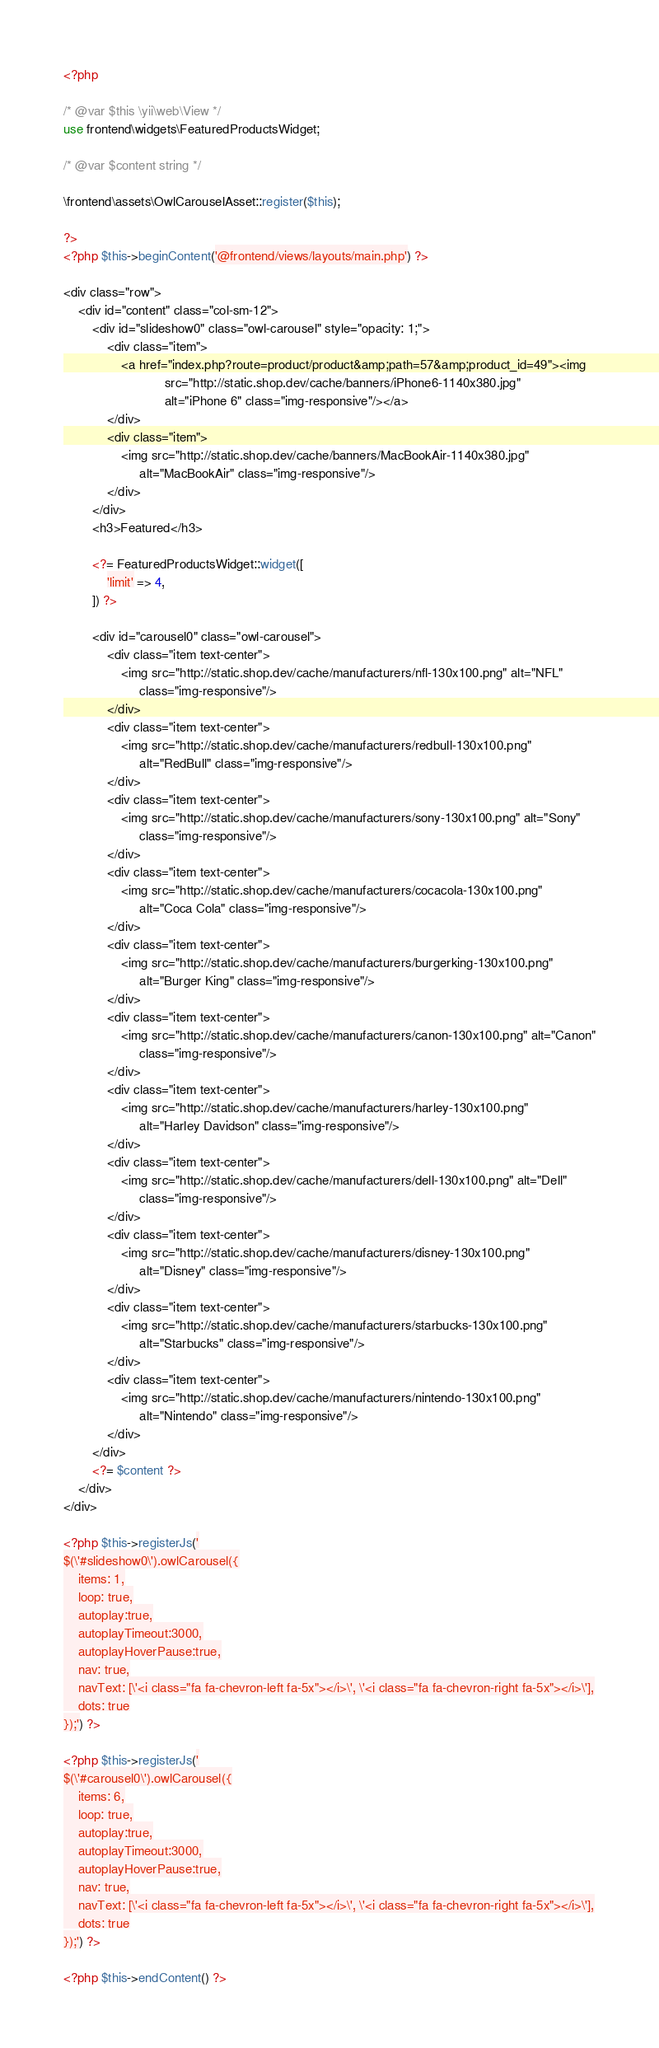<code> <loc_0><loc_0><loc_500><loc_500><_PHP_><?php

/* @var $this \yii\web\View */
use frontend\widgets\FeaturedProductsWidget;

/* @var $content string */

\frontend\assets\OwlCarouselAsset::register($this);

?>
<?php $this->beginContent('@frontend/views/layouts/main.php') ?>

<div class="row">
    <div id="content" class="col-sm-12">
        <div id="slideshow0" class="owl-carousel" style="opacity: 1;">
            <div class="item">
                <a href="index.php?route=product/product&amp;path=57&amp;product_id=49"><img
                            src="http://static.shop.dev/cache/banners/iPhone6-1140x380.jpg"
                            alt="iPhone 6" class="img-responsive"/></a>
            </div>
            <div class="item">
                <img src="http://static.shop.dev/cache/banners/MacBookAir-1140x380.jpg"
                     alt="MacBookAir" class="img-responsive"/>
            </div>
        </div>
        <h3>Featured</h3>

        <?= FeaturedProductsWidget::widget([
            'limit' => 4,
        ]) ?>

        <div id="carousel0" class="owl-carousel">
            <div class="item text-center">
                <img src="http://static.shop.dev/cache/manufacturers/nfl-130x100.png" alt="NFL"
                     class="img-responsive"/>
            </div>
            <div class="item text-center">
                <img src="http://static.shop.dev/cache/manufacturers/redbull-130x100.png"
                     alt="RedBull" class="img-responsive"/>
            </div>
            <div class="item text-center">
                <img src="http://static.shop.dev/cache/manufacturers/sony-130x100.png" alt="Sony"
                     class="img-responsive"/>
            </div>
            <div class="item text-center">
                <img src="http://static.shop.dev/cache/manufacturers/cocacola-130x100.png"
                     alt="Coca Cola" class="img-responsive"/>
            </div>
            <div class="item text-center">
                <img src="http://static.shop.dev/cache/manufacturers/burgerking-130x100.png"
                     alt="Burger King" class="img-responsive"/>
            </div>
            <div class="item text-center">
                <img src="http://static.shop.dev/cache/manufacturers/canon-130x100.png" alt="Canon"
                     class="img-responsive"/>
            </div>
            <div class="item text-center">
                <img src="http://static.shop.dev/cache/manufacturers/harley-130x100.png"
                     alt="Harley Davidson" class="img-responsive"/>
            </div>
            <div class="item text-center">
                <img src="http://static.shop.dev/cache/manufacturers/dell-130x100.png" alt="Dell"
                     class="img-responsive"/>
            </div>
            <div class="item text-center">
                <img src="http://static.shop.dev/cache/manufacturers/disney-130x100.png"
                     alt="Disney" class="img-responsive"/>
            </div>
            <div class="item text-center">
                <img src="http://static.shop.dev/cache/manufacturers/starbucks-130x100.png"
                     alt="Starbucks" class="img-responsive"/>
            </div>
            <div class="item text-center">
                <img src="http://static.shop.dev/cache/manufacturers/nintendo-130x100.png"
                     alt="Nintendo" class="img-responsive"/>
            </div>
        </div>
        <?= $content ?>
    </div>
</div>

<?php $this->registerJs('
$(\'#slideshow0\').owlCarousel({
    items: 1,
    loop: true,
    autoplay:true,
    autoplayTimeout:3000,
    autoplayHoverPause:true,
    nav: true,
    navText: [\'<i class="fa fa-chevron-left fa-5x"></i>\', \'<i class="fa fa-chevron-right fa-5x"></i>\'],
    dots: true
});') ?>

<?php $this->registerJs('
$(\'#carousel0\').owlCarousel({
    items: 6,
    loop: true,
    autoplay:true,
    autoplayTimeout:3000,
    autoplayHoverPause:true,
    nav: true,
    navText: [\'<i class="fa fa-chevron-left fa-5x"></i>\', \'<i class="fa fa-chevron-right fa-5x"></i>\'],
    dots: true
});') ?>

<?php $this->endContent() ?></code> 